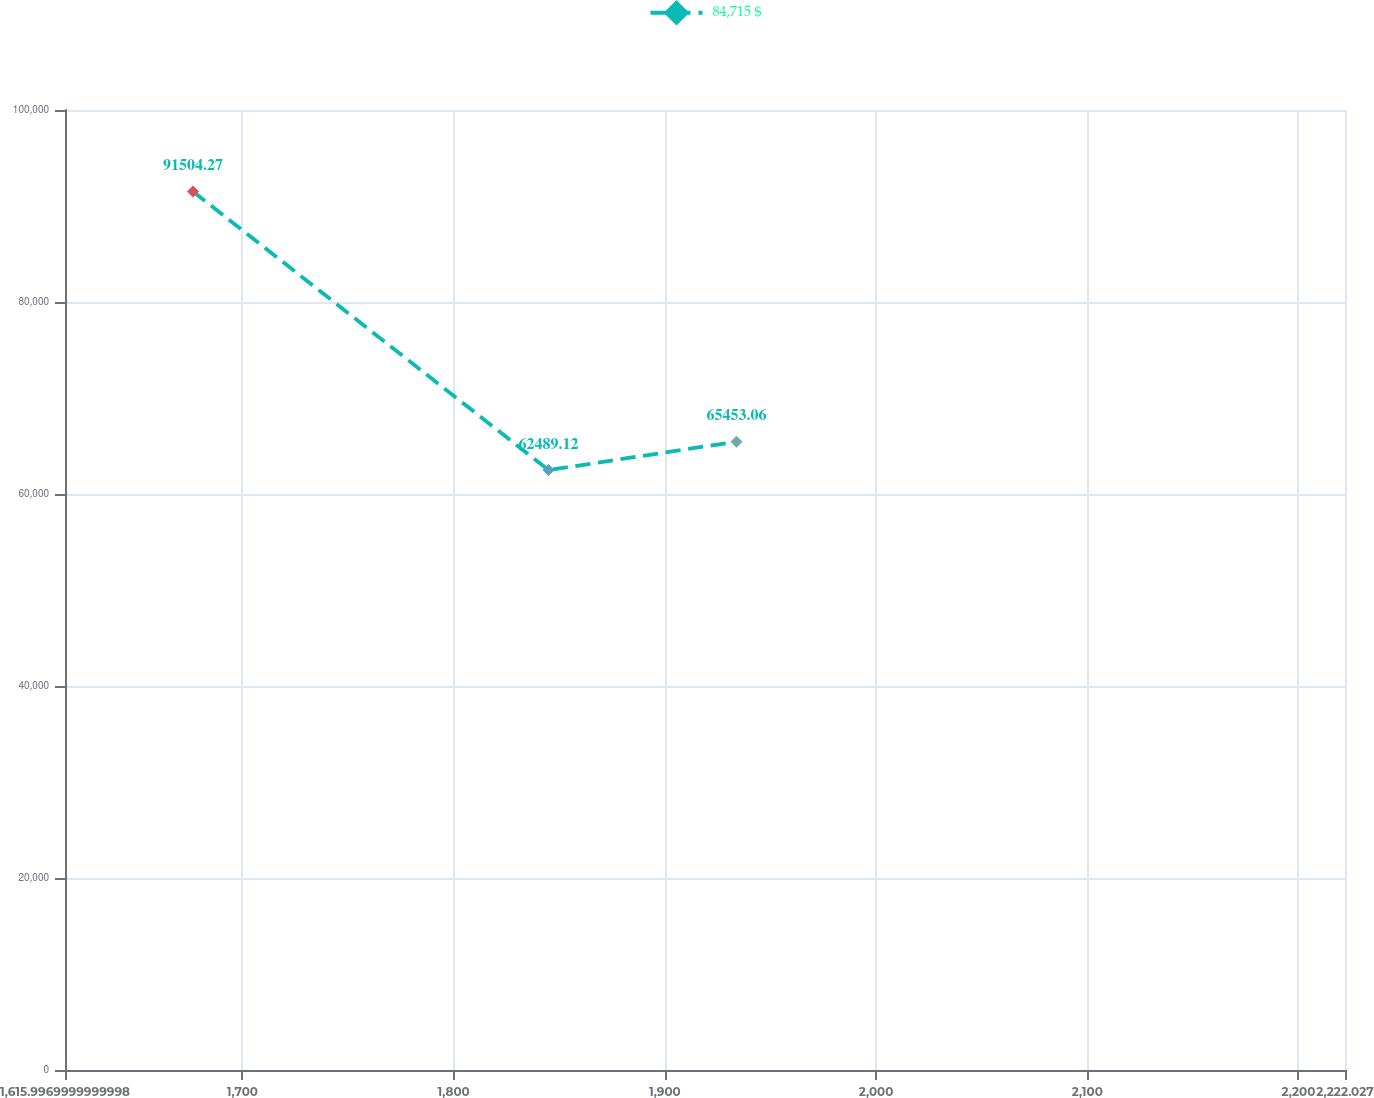Convert chart to OTSL. <chart><loc_0><loc_0><loc_500><loc_500><line_chart><ecel><fcel>84,715 $<nl><fcel>1676.6<fcel>91504.3<nl><fcel>1844.93<fcel>62489.1<nl><fcel>1933.92<fcel>65453.1<nl><fcel>2282.63<fcel>74667<nl></chart> 